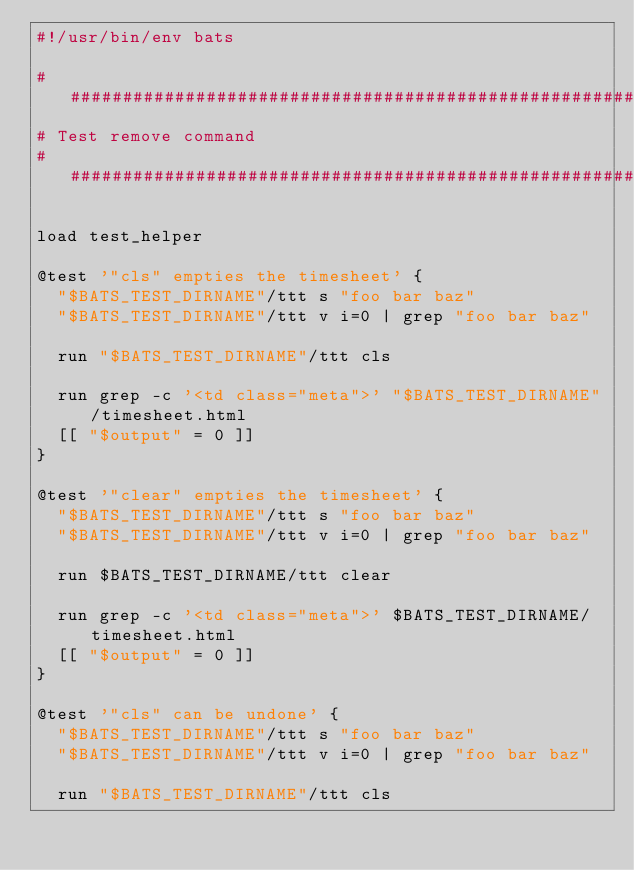Convert code to text. <code><loc_0><loc_0><loc_500><loc_500><_Bash_>#!/usr/bin/env bats

########################################################################################################################
# Test remove command
########################################################################################################################

load test_helper

@test '"cls" empties the timesheet' {
  "$BATS_TEST_DIRNAME"/ttt s "foo bar baz"
  "$BATS_TEST_DIRNAME"/ttt v i=0 | grep "foo bar baz"

  run "$BATS_TEST_DIRNAME"/ttt cls

  run grep -c '<td class="meta">' "$BATS_TEST_DIRNAME"/timesheet.html
  [[ "$output" = 0 ]]
}

@test '"clear" empties the timesheet' {
  "$BATS_TEST_DIRNAME"/ttt s "foo bar baz"
  "$BATS_TEST_DIRNAME"/ttt v i=0 | grep "foo bar baz"

  run $BATS_TEST_DIRNAME/ttt clear

  run grep -c '<td class="meta">' $BATS_TEST_DIRNAME/timesheet.html
  [[ "$output" = 0 ]]
}

@test '"cls" can be undone' {
  "$BATS_TEST_DIRNAME"/ttt s "foo bar baz"
  "$BATS_TEST_DIRNAME"/ttt v i=0 | grep "foo bar baz"

  run "$BATS_TEST_DIRNAME"/ttt cls
</code> 